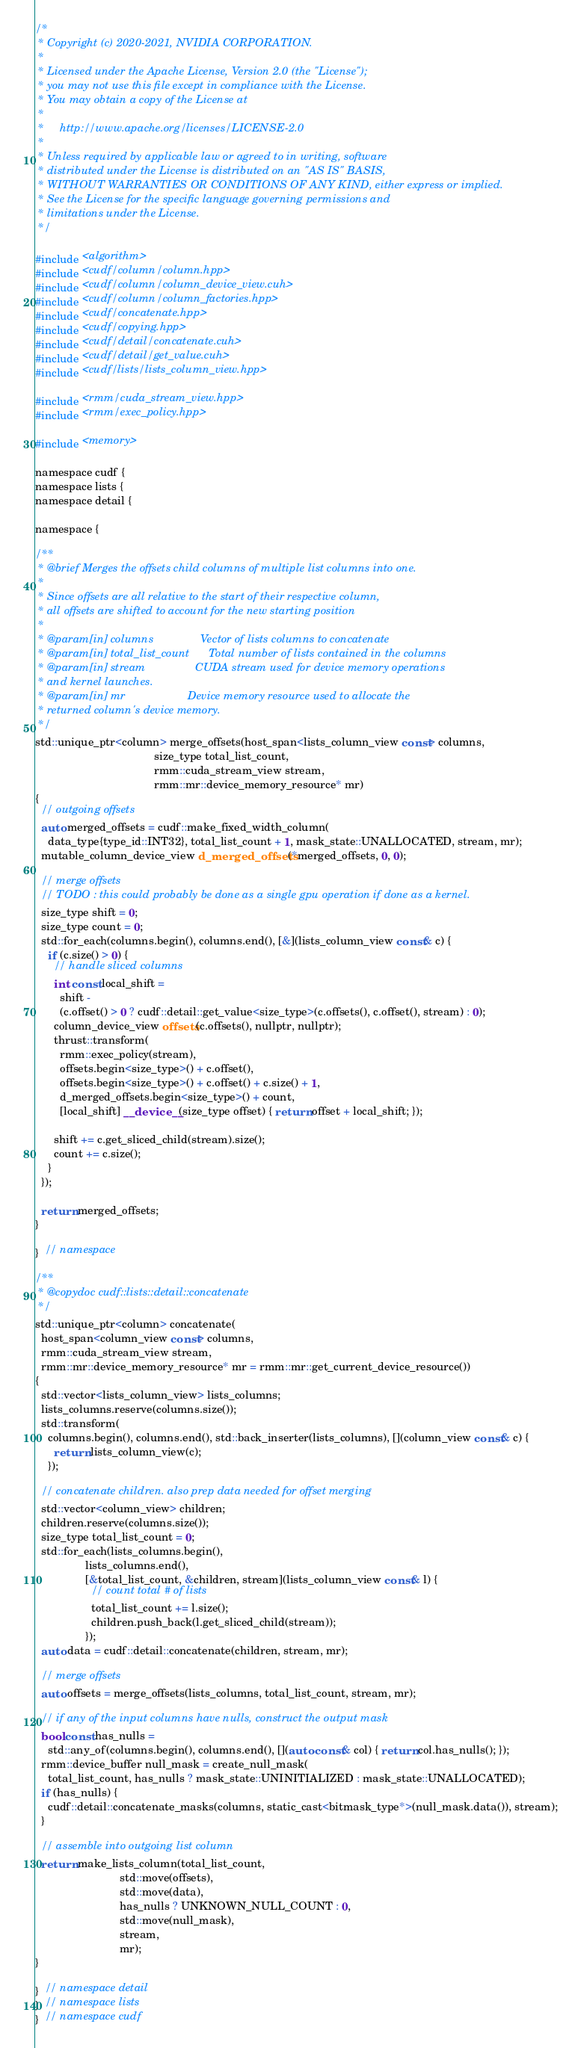<code> <loc_0><loc_0><loc_500><loc_500><_Cuda_>/*
 * Copyright (c) 2020-2021, NVIDIA CORPORATION.
 *
 * Licensed under the Apache License, Version 2.0 (the "License");
 * you may not use this file except in compliance with the License.
 * You may obtain a copy of the License at
 *
 *     http://www.apache.org/licenses/LICENSE-2.0
 *
 * Unless required by applicable law or agreed to in writing, software
 * distributed under the License is distributed on an "AS IS" BASIS,
 * WITHOUT WARRANTIES OR CONDITIONS OF ANY KIND, either express or implied.
 * See the License for the specific language governing permissions and
 * limitations under the License.
 */

#include <algorithm>
#include <cudf/column/column.hpp>
#include <cudf/column/column_device_view.cuh>
#include <cudf/column/column_factories.hpp>
#include <cudf/concatenate.hpp>
#include <cudf/copying.hpp>
#include <cudf/detail/concatenate.cuh>
#include <cudf/detail/get_value.cuh>
#include <cudf/lists/lists_column_view.hpp>

#include <rmm/cuda_stream_view.hpp>
#include <rmm/exec_policy.hpp>

#include <memory>

namespace cudf {
namespace lists {
namespace detail {

namespace {

/**
 * @brief Merges the offsets child columns of multiple list columns into one.
 *
 * Since offsets are all relative to the start of their respective column,
 * all offsets are shifted to account for the new starting position
 *
 * @param[in] columns               Vector of lists columns to concatenate
 * @param[in] total_list_count      Total number of lists contained in the columns
 * @param[in] stream                CUDA stream used for device memory operations
 * and kernel launches.
 * @param[in] mr                    Device memory resource used to allocate the
 * returned column's device memory.
 */
std::unique_ptr<column> merge_offsets(host_span<lists_column_view const> columns,
                                      size_type total_list_count,
                                      rmm::cuda_stream_view stream,
                                      rmm::mr::device_memory_resource* mr)
{
  // outgoing offsets
  auto merged_offsets = cudf::make_fixed_width_column(
    data_type{type_id::INT32}, total_list_count + 1, mask_state::UNALLOCATED, stream, mr);
  mutable_column_device_view d_merged_offsets(*merged_offsets, 0, 0);

  // merge offsets
  // TODO : this could probably be done as a single gpu operation if done as a kernel.
  size_type shift = 0;
  size_type count = 0;
  std::for_each(columns.begin(), columns.end(), [&](lists_column_view const& c) {
    if (c.size() > 0) {
      // handle sliced columns
      int const local_shift =
        shift -
        (c.offset() > 0 ? cudf::detail::get_value<size_type>(c.offsets(), c.offset(), stream) : 0);
      column_device_view offsets(c.offsets(), nullptr, nullptr);
      thrust::transform(
        rmm::exec_policy(stream),
        offsets.begin<size_type>() + c.offset(),
        offsets.begin<size_type>() + c.offset() + c.size() + 1,
        d_merged_offsets.begin<size_type>() + count,
        [local_shift] __device__(size_type offset) { return offset + local_shift; });

      shift += c.get_sliced_child(stream).size();
      count += c.size();
    }
  });

  return merged_offsets;
}

}  // namespace

/**
 * @copydoc cudf::lists::detail::concatenate
 */
std::unique_ptr<column> concatenate(
  host_span<column_view const> columns,
  rmm::cuda_stream_view stream,
  rmm::mr::device_memory_resource* mr = rmm::mr::get_current_device_resource())
{
  std::vector<lists_column_view> lists_columns;
  lists_columns.reserve(columns.size());
  std::transform(
    columns.begin(), columns.end(), std::back_inserter(lists_columns), [](column_view const& c) {
      return lists_column_view(c);
    });

  // concatenate children. also prep data needed for offset merging
  std::vector<column_view> children;
  children.reserve(columns.size());
  size_type total_list_count = 0;
  std::for_each(lists_columns.begin(),
                lists_columns.end(),
                [&total_list_count, &children, stream](lists_column_view const& l) {
                  // count total # of lists
                  total_list_count += l.size();
                  children.push_back(l.get_sliced_child(stream));
                });
  auto data = cudf::detail::concatenate(children, stream, mr);

  // merge offsets
  auto offsets = merge_offsets(lists_columns, total_list_count, stream, mr);

  // if any of the input columns have nulls, construct the output mask
  bool const has_nulls =
    std::any_of(columns.begin(), columns.end(), [](auto const& col) { return col.has_nulls(); });
  rmm::device_buffer null_mask = create_null_mask(
    total_list_count, has_nulls ? mask_state::UNINITIALIZED : mask_state::UNALLOCATED);
  if (has_nulls) {
    cudf::detail::concatenate_masks(columns, static_cast<bitmask_type*>(null_mask.data()), stream);
  }

  // assemble into outgoing list column
  return make_lists_column(total_list_count,
                           std::move(offsets),
                           std::move(data),
                           has_nulls ? UNKNOWN_NULL_COUNT : 0,
                           std::move(null_mask),
                           stream,
                           mr);
}

}  // namespace detail
}  // namespace lists
}  // namespace cudf
</code> 